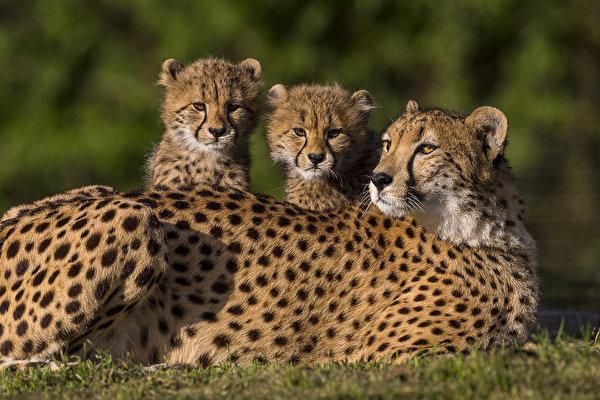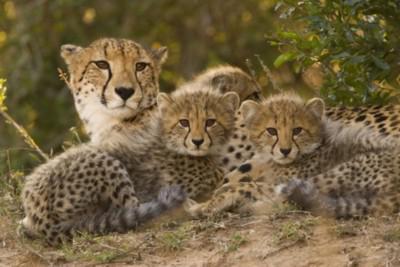The first image is the image on the left, the second image is the image on the right. Assess this claim about the two images: "There are more spotted wild cats in the left image than in the right.". Correct or not? Answer yes or no. No. The first image is the image on the left, the second image is the image on the right. Given the left and right images, does the statement "In one of the images, you can see one of the animal's tongues." hold true? Answer yes or no. No. 